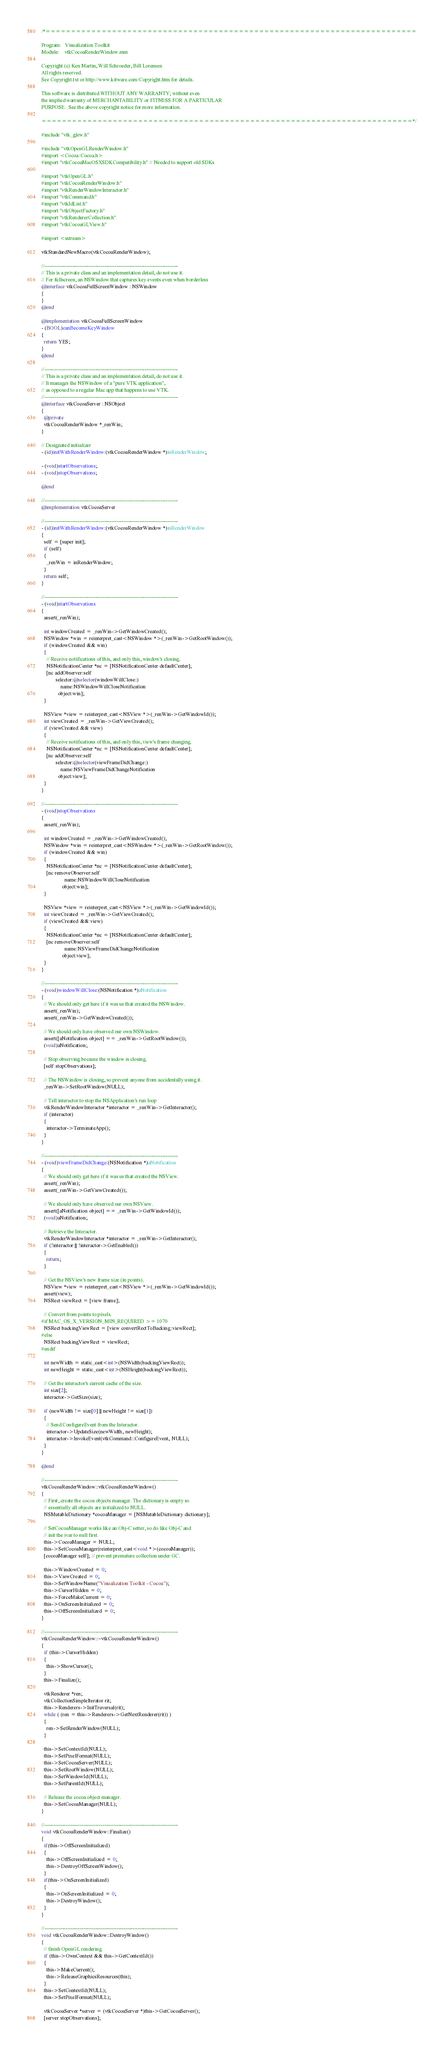<code> <loc_0><loc_0><loc_500><loc_500><_ObjectiveC_>/*=========================================================================

Program:   Visualization Toolkit
Module:    vtkCocoaRenderWindow.mm

Copyright (c) Ken Martin, Will Schroeder, Bill Lorensen
All rights reserved.
See Copyright.txt or http://www.kitware.com/Copyright.htm for details.

This software is distributed WITHOUT ANY WARRANTY; without even
the implied warranty of MERCHANTABILITY or FITNESS FOR A PARTICULAR
PURPOSE.  See the above copyright notice for more information.

=========================================================================*/

#include "vtk_glew.h"

#include "vtkOpenGLRenderWindow.h"
#import <Cocoa/Cocoa.h>
#import "vtkCocoaMacOSXSDKCompatibility.h" // Needed to support old SDKs

#import "vtkOpenGL.h"
#import "vtkCocoaRenderWindow.h"
#import "vtkRenderWindowInteractor.h"
#import "vtkCommand.h"
#import "vtkIdList.h"
#import "vtkObjectFactory.h"
#import "vtkRendererCollection.h"
#import "vtkCocoaGLView.h"

#import <sstream>

vtkStandardNewMacro(vtkCocoaRenderWindow);

//----------------------------------------------------------------------------
// This is a private class and an implementation detail, do not use it.
// For fullscreen, an NSWindow that captures key events even when borderless
@interface vtkCocoaFullScreenWindow : NSWindow
{
}
@end

@implementation vtkCocoaFullScreenWindow
- (BOOL)canBecomeKeyWindow
{
  return YES;
}
@end

//----------------------------------------------------------------------------
// This is a private class and an implementation detail, do not use it.
// It manages the NSWindow of a "pure VTK application",
// as opposed to a regular Mac app that happens to use VTK.
//----------------------------------------------------------------------------
@interface vtkCocoaServer : NSObject
{
  @private
  vtkCocoaRenderWindow *_renWin;
}

// Designated initializer
- (id)initWithRenderWindow:(vtkCocoaRenderWindow *)inRenderWindow;

- (void)startObservations;
- (void)stopObservations;

@end

//----------------------------------------------------------------------------
@implementation vtkCocoaServer

//----------------------------------------------------------------------------
- (id)initWithRenderWindow:(vtkCocoaRenderWindow *)inRenderWindow
{
  self = [super init];
  if (self)
  {
    _renWin = inRenderWindow;
  }
  return self;
}

//----------------------------------------------------------------------------
- (void)startObservations
{
  assert(_renWin);

  int windowCreated = _renWin->GetWindowCreated();
  NSWindow *win = reinterpret_cast<NSWindow *>(_renWin->GetRootWindow());
  if (windowCreated && win)
  {
    // Receive notifications of this, and only this, window's closing.
    NSNotificationCenter *nc = [NSNotificationCenter defaultCenter];
    [nc addObserver:self
           selector:@selector(windowWillClose:)
               name:NSWindowWillCloseNotification
             object:win];
  }

  NSView *view = reinterpret_cast<NSView *>(_renWin->GetWindowId());
  int viewCreated = _renWin->GetViewCreated();
  if (viewCreated && view)
  {
    // Receive notifications of this, and only this, view's frame changing.
    NSNotificationCenter *nc = [NSNotificationCenter defaultCenter];
    [nc addObserver:self
           selector:@selector(viewFrameDidChange:)
               name:NSViewFrameDidChangeNotification
             object:view];
  }
}

//----------------------------------------------------------------------------
- (void)stopObservations
{
  assert(_renWin);

  int windowCreated = _renWin->GetWindowCreated();
  NSWindow *win = reinterpret_cast<NSWindow *>(_renWin->GetRootWindow());
  if (windowCreated && win)
  {
    NSNotificationCenter *nc = [NSNotificationCenter defaultCenter];
    [nc removeObserver:self
                  name:NSWindowWillCloseNotification
                object:win];
  }

  NSView *view = reinterpret_cast<NSView *>(_renWin->GetWindowId());
  int viewCreated = _renWin->GetViewCreated();
  if (viewCreated && view)
  {
    NSNotificationCenter *nc = [NSNotificationCenter defaultCenter];
    [nc removeObserver:self
                  name:NSViewFrameDidChangeNotification
                object:view];
  }
}

//----------------------------------------------------------------------------
- (void)windowWillClose:(NSNotification *)aNotification
{
  // We should only get here if it was us that created the NSWindow.
  assert(_renWin);
  assert(_renWin->GetWindowCreated());

  // We should only have observed our own NSWindow.
  assert([aNotification object] == _renWin->GetRootWindow());
  (void)aNotification;

  // Stop observing because the window is closing.
  [self stopObservations];

  // The NSWindow is closing, so prevent anyone from accidentally using it.
  _renWin->SetRootWindow(NULL);

  // Tell interactor to stop the NSApplication's run loop
  vtkRenderWindowInteractor *interactor = _renWin->GetInteractor();
  if (interactor)
  {
    interactor->TerminateApp();
  }
}

//----------------------------------------------------------------------------
- (void)viewFrameDidChange:(NSNotification *)aNotification
{
  // We should only get here if it was us that created the NSView.
  assert(_renWin);
  assert(_renWin->GetViewCreated());

  // We should only have observed our own NSView.
  assert([aNotification object] == _renWin->GetWindowId());
  (void)aNotification;

  // Retrieve the Interactor.
  vtkRenderWindowInteractor *interactor = _renWin->GetInteractor();
  if (!interactor || !interactor->GetEnabled())
  {
    return;
  }

  // Get the NSView's new frame size (in points).
  NSView *view = reinterpret_cast<NSView *>(_renWin->GetWindowId());
  assert(view);
  NSRect viewRect = [view frame];

  // Convert from points to pixels.
#if MAC_OS_X_VERSION_MIN_REQUIRED >= 1070
  NSRect backingViewRect = [view convertRectToBacking:viewRect];
#else
  NSRect backingViewRect = viewRect;
#endif

  int newWidth = static_cast<int>(NSWidth(backingViewRect));
  int newHeight = static_cast<int>(NSHeight(backingViewRect));

  // Get the interactor's current cache of the size.
  int size[2];
  interactor->GetSize(size);

  if (newWidth != size[0] || newHeight != size[1])
  {
    // Send ConfigureEvent from the Interactor.
    interactor->UpdateSize(newWidth, newHeight);
    interactor->InvokeEvent(vtkCommand::ConfigureEvent, NULL);
  }
}

@end

//----------------------------------------------------------------------------
vtkCocoaRenderWindow::vtkCocoaRenderWindow()
{
  // First, create the cocoa objects manager. The dictionary is empty so
  // essentially all objects are initialized to NULL.
  NSMutableDictionary *cocoaManager = [NSMutableDictionary dictionary];

  // SetCocoaManager works like an Obj-C setter, so do like Obj-C and
  // init the ivar to null first.
  this->CocoaManager = NULL;
  this->SetCocoaManager(reinterpret_cast<void *>(cocoaManager));
  [cocoaManager self]; // prevent premature collection under GC.

  this->WindowCreated = 0;
  this->ViewCreated = 0;
  this->SetWindowName("Visualization Toolkit - Cocoa");
  this->CursorHidden = 0;
  this->ForceMakeCurrent = 0;
  this->OnScreenInitialized = 0;
  this->OffScreenInitialized = 0;
}

//----------------------------------------------------------------------------
vtkCocoaRenderWindow::~vtkCocoaRenderWindow()
{
  if (this->CursorHidden)
  {
    this->ShowCursor();
  }
  this->Finalize();

  vtkRenderer *ren;
  vtkCollectionSimpleIterator rit;
  this->Renderers->InitTraversal(rit);
  while ( (ren = this->Renderers->GetNextRenderer(rit)) )
  {
    ren->SetRenderWindow(NULL);
  }

  this->SetContextId(NULL);
  this->SetPixelFormat(NULL);
  this->SetCocoaServer(NULL);
  this->SetRootWindow(NULL);
  this->SetWindowId(NULL);
  this->SetParentId(NULL);

  // Release the cocoa object manager.
  this->SetCocoaManager(NULL);
}

//----------------------------------------------------------------------------
void vtkCocoaRenderWindow::Finalize()
{
  if(this->OffScreenInitialized)
  {
    this->OffScreenInitialized = 0;
    this->DestroyOffScreenWindow();
  }
  if(this->OnScreenInitialized)
  {
    this->OnScreenInitialized = 0;
    this->DestroyWindow();
  }
}

//----------------------------------------------------------------------------
void vtkCocoaRenderWindow::DestroyWindow()
{
  // finish OpenGL rendering
  if (this->OwnContext && this->GetContextId())
  {
    this->MakeCurrent();
    this->ReleaseGraphicsResources(this);
  }
  this->SetContextId(NULL);
  this->SetPixelFormat(NULL);

  vtkCocoaServer *server = (vtkCocoaServer *)this->GetCocoaServer();
  [server stopObservations];</code> 